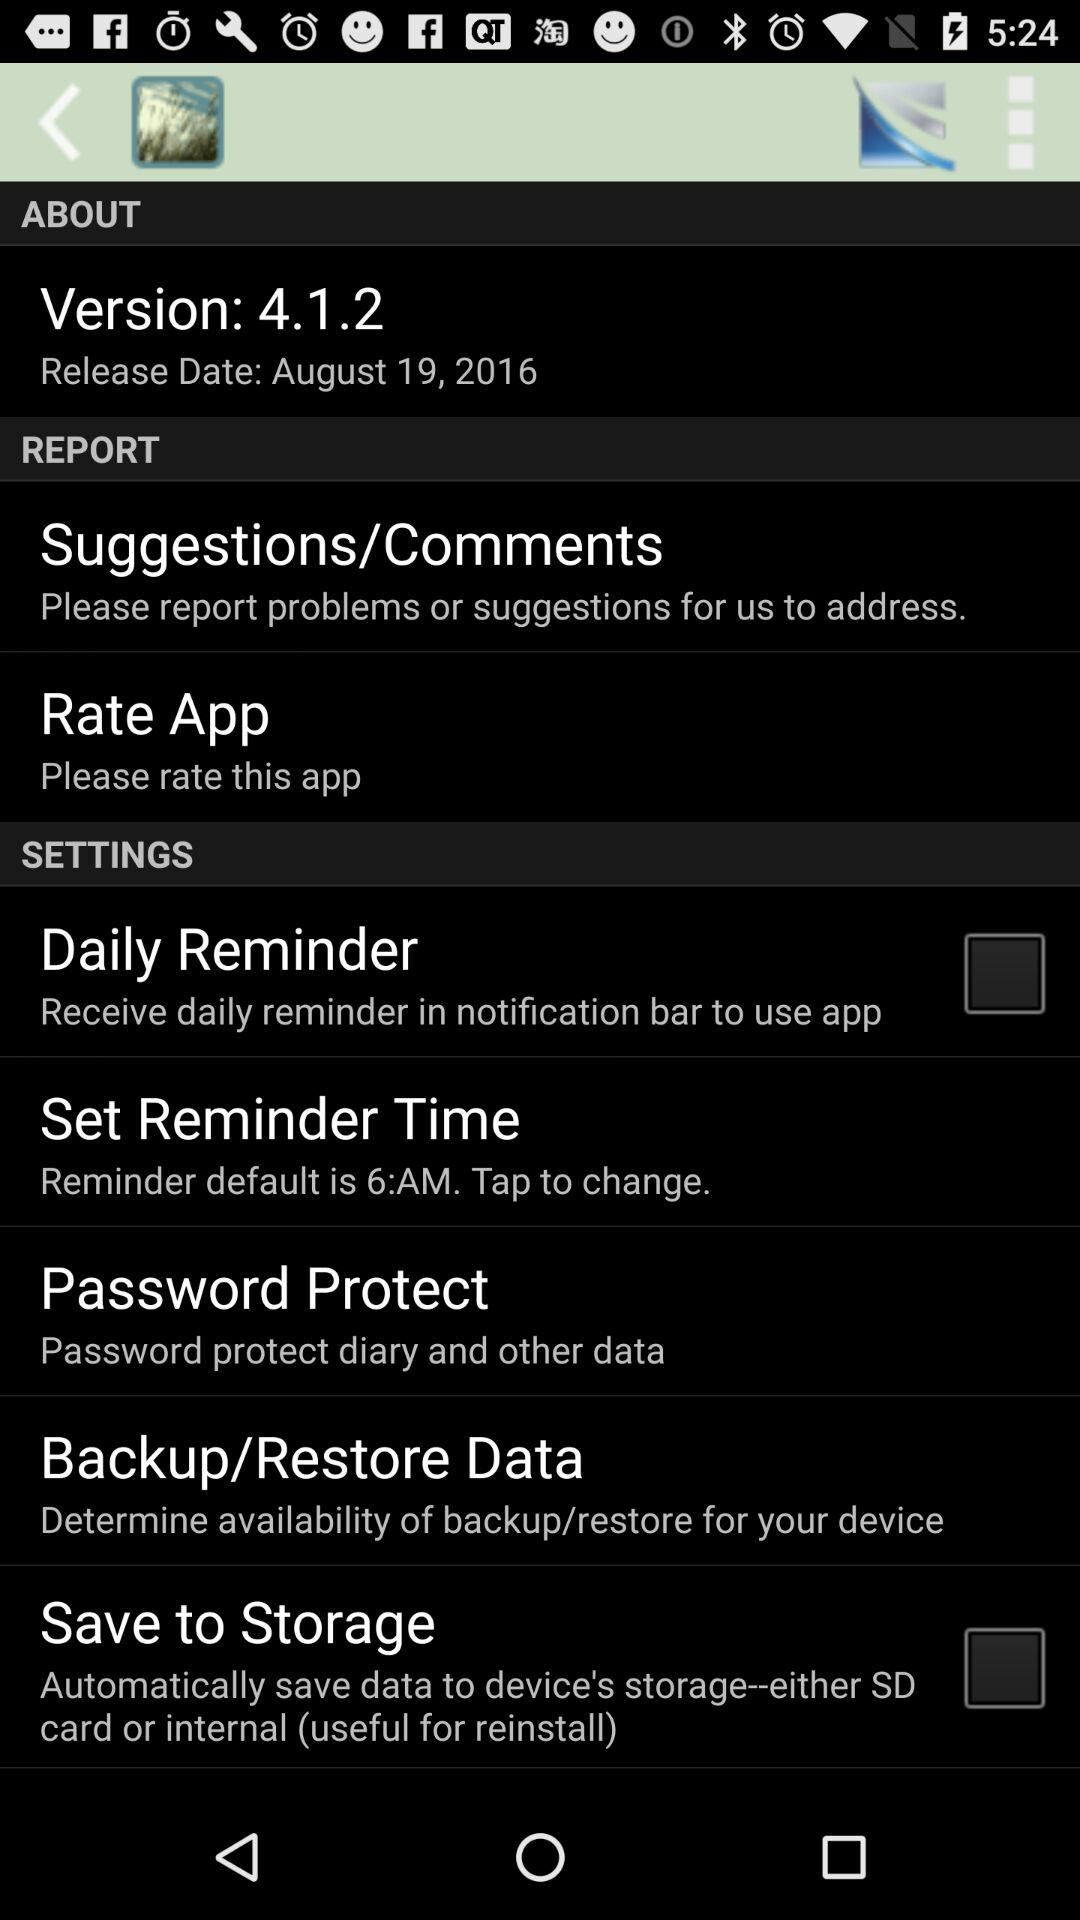What is the version number? The version number is 4.1.2. 